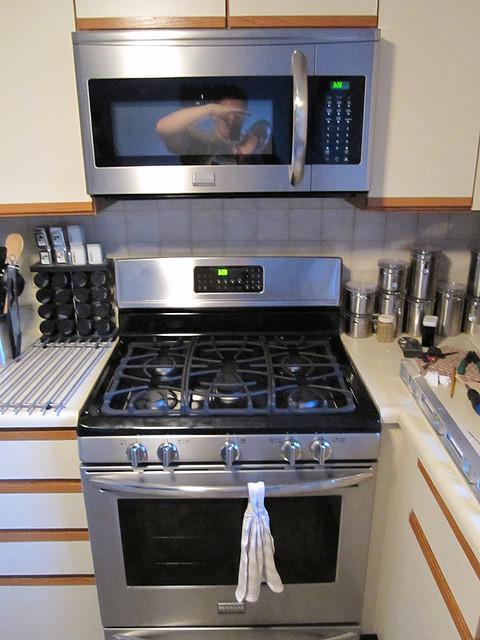How many people are reflected in the microwave window?
Give a very brief answer. 1. How many shades of brown?
Give a very brief answer. 1. How many zebras in the picture?
Give a very brief answer. 0. 